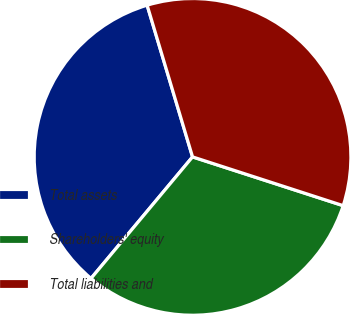Convert chart to OTSL. <chart><loc_0><loc_0><loc_500><loc_500><pie_chart><fcel>Total assets<fcel>Shareholders' equity<fcel>Total liabilities and<nl><fcel>34.29%<fcel>31.09%<fcel>34.61%<nl></chart> 